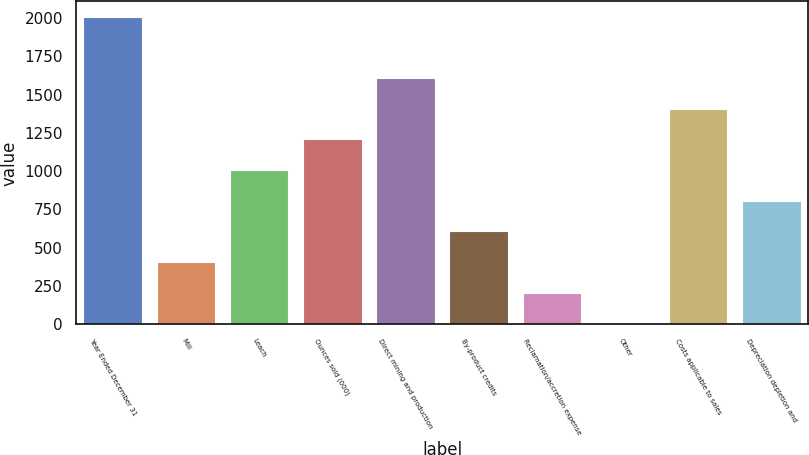<chart> <loc_0><loc_0><loc_500><loc_500><bar_chart><fcel>Year Ended December 31<fcel>Mill<fcel>Leach<fcel>Ounces sold (000)<fcel>Direct mining and production<fcel>By-product credits<fcel>Reclamation/accretion expense<fcel>Other<fcel>Costs applicable to sales<fcel>Depreciation depletion and<nl><fcel>2007<fcel>407<fcel>1007<fcel>1207<fcel>1607<fcel>607<fcel>207<fcel>7<fcel>1407<fcel>807<nl></chart> 